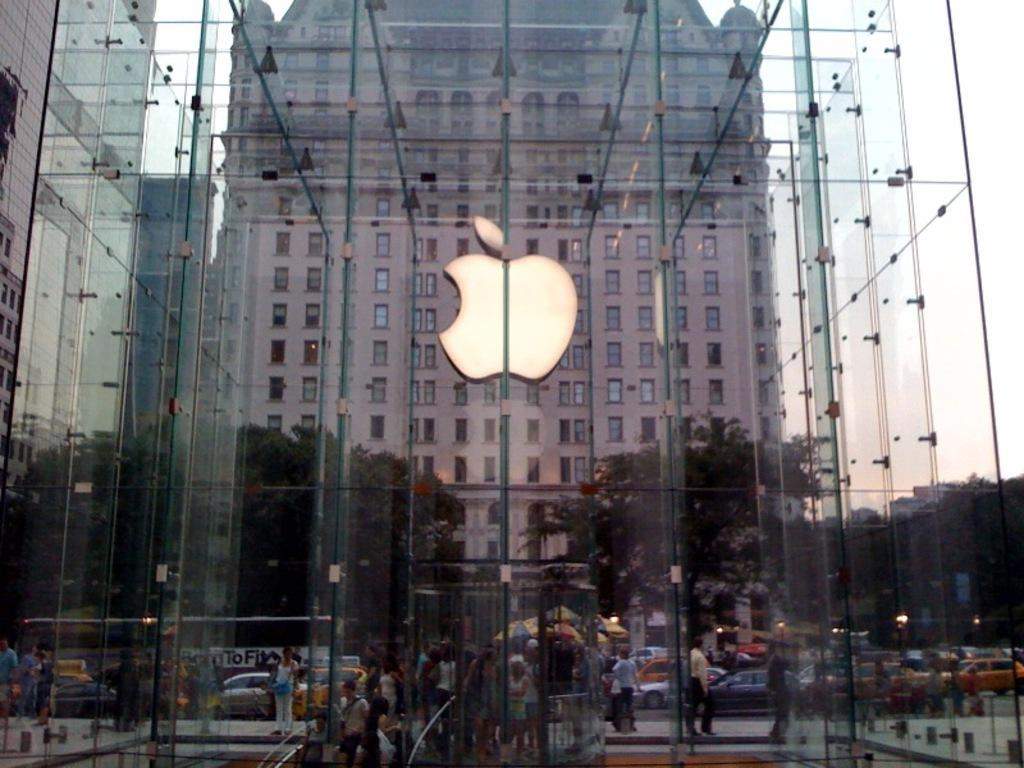What is the main structure in the center of the image? There is a glass building in the center of the image. What can be seen in the background of the image? There are buildings, trees, persons, vehicles, tents, lights, and poles visible in the background of the image. Can you describe the other objects present in the background of the image? There are other objects in the background of the image, but their specific details are not mentioned in the provided facts. Is the seashore visible in the image? No, the seashore is not visible in the image. What is the power consumption of the lights in the image? The power consumption of the lights cannot be determined from the image, as their specific details are not mentioned in the provided facts. 